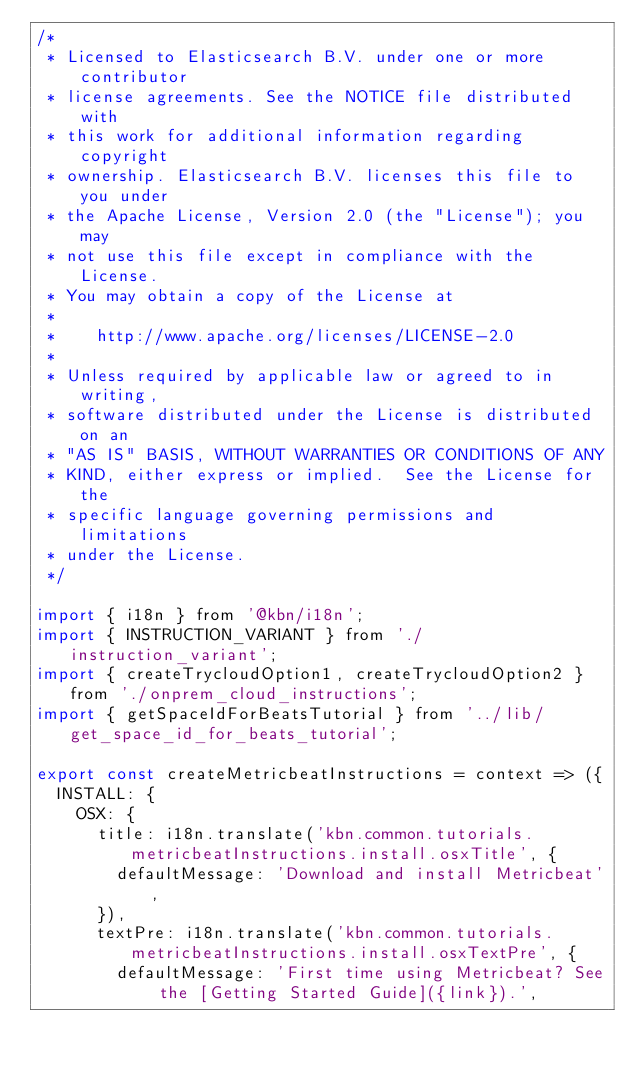Convert code to text. <code><loc_0><loc_0><loc_500><loc_500><_JavaScript_>/*
 * Licensed to Elasticsearch B.V. under one or more contributor
 * license agreements. See the NOTICE file distributed with
 * this work for additional information regarding copyright
 * ownership. Elasticsearch B.V. licenses this file to you under
 * the Apache License, Version 2.0 (the "License"); you may
 * not use this file except in compliance with the License.
 * You may obtain a copy of the License at
 *
 *    http://www.apache.org/licenses/LICENSE-2.0
 *
 * Unless required by applicable law or agreed to in writing,
 * software distributed under the License is distributed on an
 * "AS IS" BASIS, WITHOUT WARRANTIES OR CONDITIONS OF ANY
 * KIND, either express or implied.  See the License for the
 * specific language governing permissions and limitations
 * under the License.
 */

import { i18n } from '@kbn/i18n';
import { INSTRUCTION_VARIANT } from './instruction_variant';
import { createTrycloudOption1, createTrycloudOption2 } from './onprem_cloud_instructions';
import { getSpaceIdForBeatsTutorial } from '../lib/get_space_id_for_beats_tutorial';

export const createMetricbeatInstructions = context => ({
  INSTALL: {
    OSX: {
      title: i18n.translate('kbn.common.tutorials.metricbeatInstructions.install.osxTitle', {
        defaultMessage: 'Download and install Metricbeat',
      }),
      textPre: i18n.translate('kbn.common.tutorials.metricbeatInstructions.install.osxTextPre', {
        defaultMessage: 'First time using Metricbeat? See the [Getting Started Guide]({link}).',</code> 